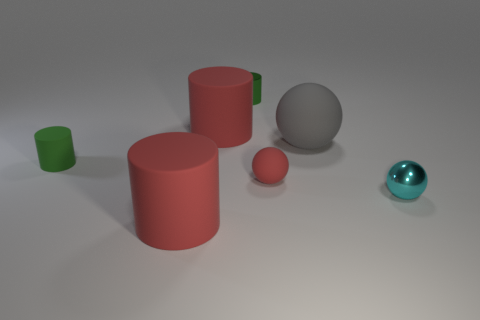There is another small thing that is the same shape as the tiny green metallic object; what is its color?
Provide a succinct answer. Green. Are there more cylinders on the right side of the small red rubber object than tiny purple matte cylinders?
Your response must be concise. No. There is a shiny thing behind the big gray matte sphere; what color is it?
Your answer should be very brief. Green. Do the green rubber cylinder and the gray matte thing have the same size?
Your answer should be compact. No. What size is the green matte thing?
Your response must be concise. Small. What is the shape of the small object that is the same color as the tiny rubber cylinder?
Offer a terse response. Cylinder. Is the number of small rubber balls greater than the number of large cyan metallic cylinders?
Keep it short and to the point. Yes. There is a tiny thing left of the green cylinder that is to the right of the big rubber cylinder that is in front of the tiny cyan thing; what is its color?
Give a very brief answer. Green. Do the tiny green object that is left of the metallic cylinder and the big gray thing have the same shape?
Your response must be concise. No. There is another matte sphere that is the same size as the cyan ball; what is its color?
Keep it short and to the point. Red. 